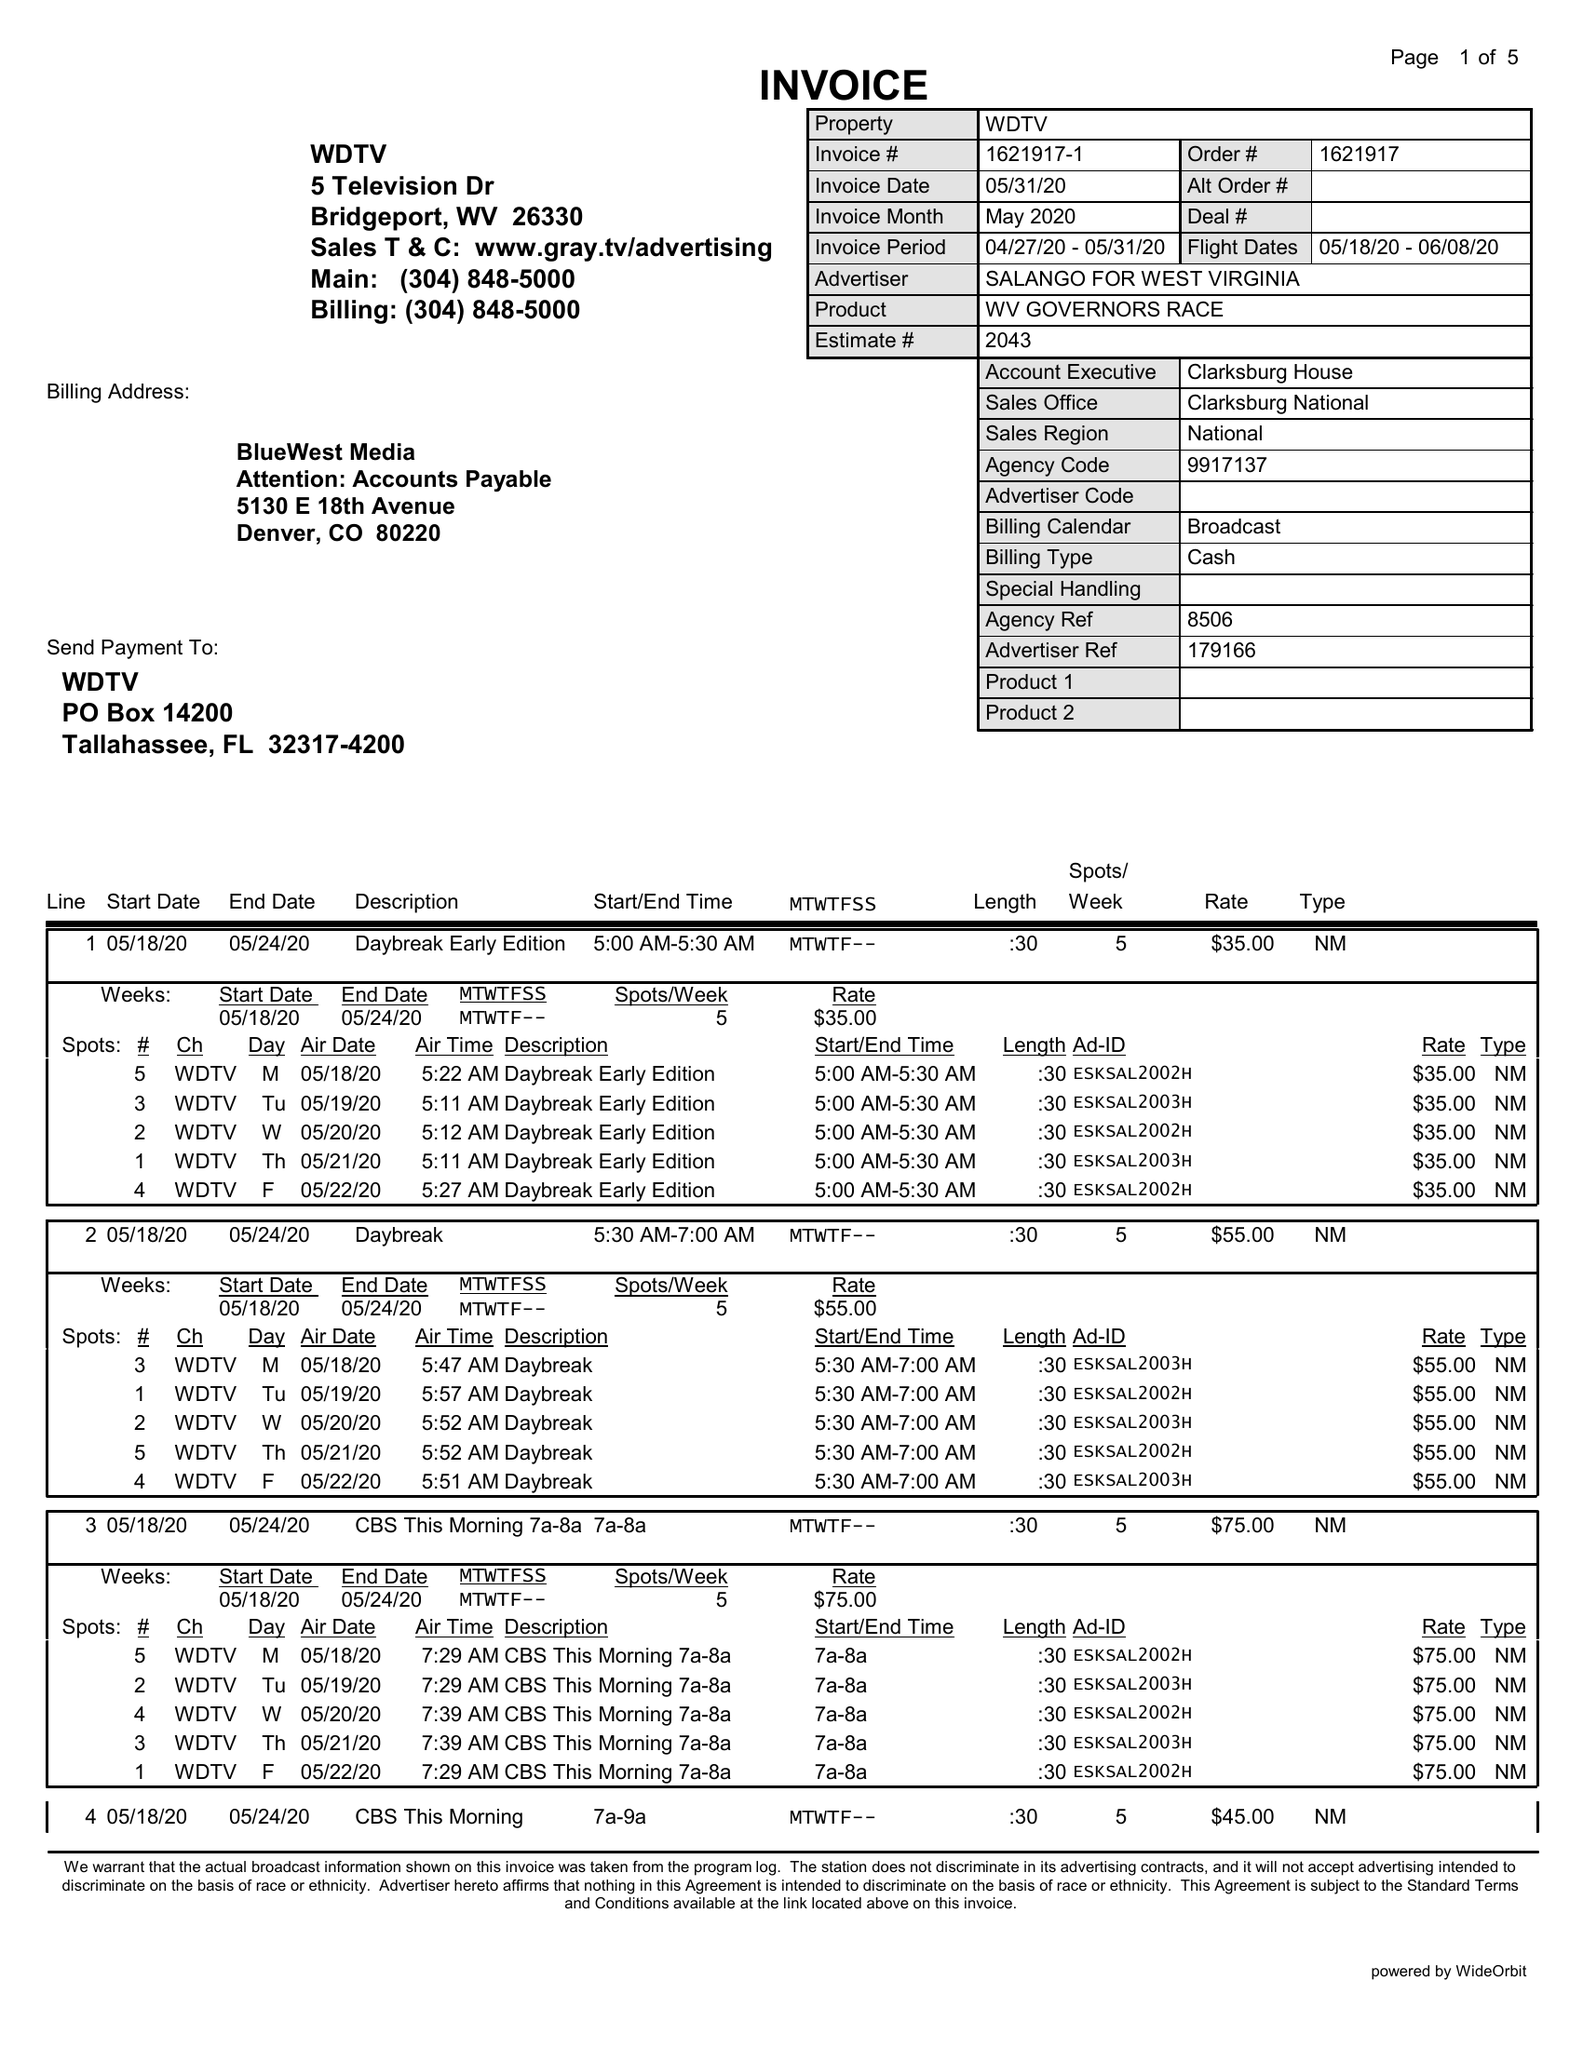What is the value for the flight_to?
Answer the question using a single word or phrase. 06/08/20 